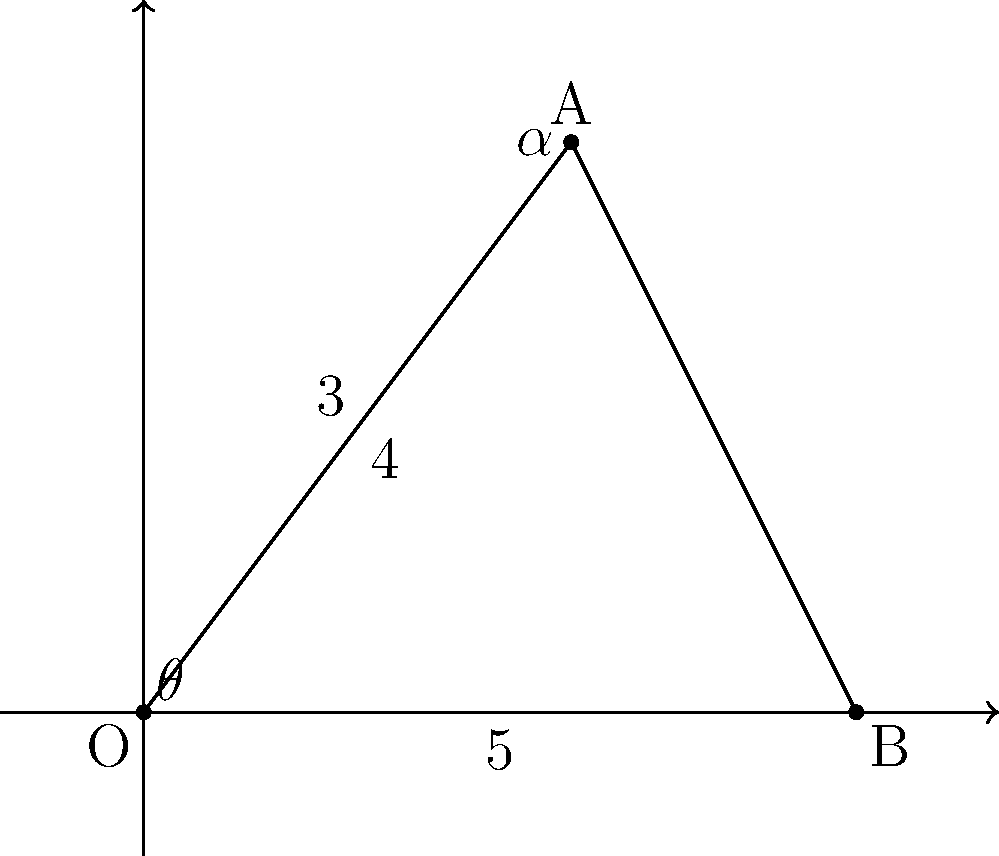A telescope mount is positioned at point O(0,0) and needs to be aligned with a celestial object at point A(3,4). The base of the mount extends to point B(5,0). To optimize the viewing angle, we need to find the angle $\theta$ between the base (OB) and the line of sight (OA). Using the given coordinate system and trigonometric principles, calculate the optimal angle $\theta$ for the telescope mount. Round your answer to the nearest degree. To find the optimal angle $\theta$, we'll follow these steps:

1) First, we need to find the length of OA using the Pythagorean theorem:
   $$OA = \sqrt{3^2 + 4^2} = \sqrt{9 + 16} = \sqrt{25} = 5$$

2) Now we have a right-angled triangle OAB, where:
   - OA = 5 (calculated)
   - OB = 5 (given)
   - AB = 4 (vertical distance)

3) We can use the inverse sine function (arcsin) to find $\theta$:
   $$\sin(\theta) = \frac{opposite}{hypotenuse} = \frac{AB}{OA} = \frac{4}{5}$$

4) Therefore:
   $$\theta = \arcsin(\frac{4}{5})$$

5) Using a calculator or computing software:
   $$\theta \approx 53.13^\circ$$

6) Rounding to the nearest degree:
   $$\theta \approx 53^\circ$$

Thus, the optimal angle for the telescope mount is approximately 53°.
Answer: 53° 